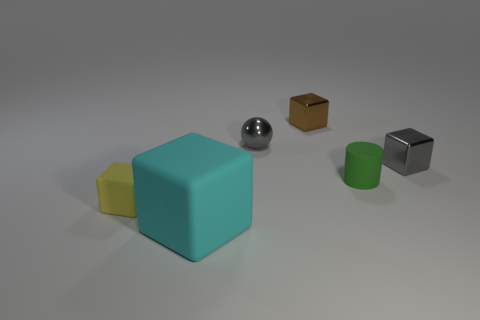Add 2 big yellow rubber cubes. How many objects exist? 8 Subtract all cyan rubber blocks. How many blocks are left? 3 Subtract all blocks. How many objects are left? 2 Add 5 small rubber blocks. How many small rubber blocks are left? 6 Add 1 green matte objects. How many green matte objects exist? 2 Subtract all yellow cubes. How many cubes are left? 3 Subtract 0 green cubes. How many objects are left? 6 Subtract 1 cylinders. How many cylinders are left? 0 Subtract all brown cubes. Subtract all yellow spheres. How many cubes are left? 3 Subtract all brown cylinders. How many yellow cubes are left? 1 